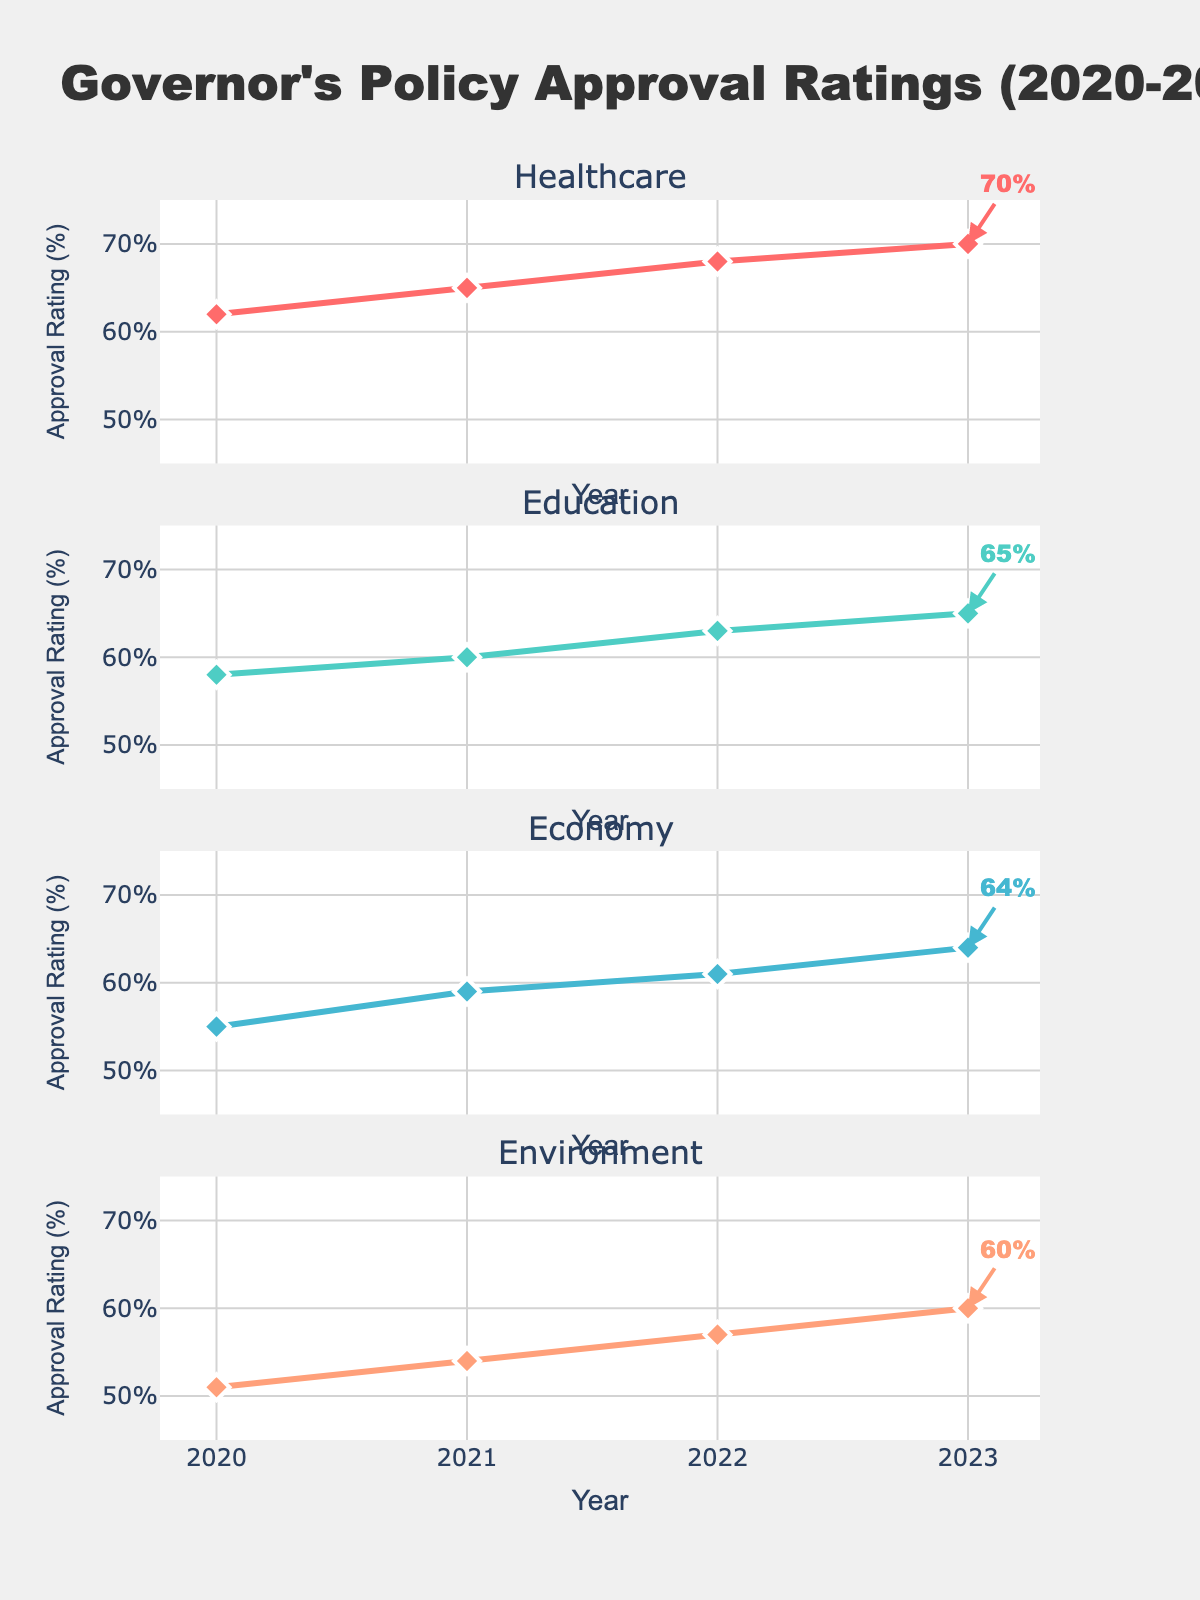What are the positions displayed in the figure? The figure has a y-axis displaying ice hockey player positions. The listed positions are: Forward, Defenseman, Goalie, Center, and Winger.
Answer: Forward, Defenseman, Goalie, Center, Winger What is the title of the figure? The title of the figure is displayed at the top and it indicates the subject of the chart. It reads, "Ice Hockey Player Statistics by Position."
Answer: Ice Hockey Player Statistics by Position Which position has the highest number of goals? By examining the horizontal bars under the "Goals" subplot, the position with the longest bar represents the highest number. Winger has the longest bar.
Answer: Winger How many assists do Centers have compared to Forwards? Under the "Assists" subplot, comparing the bars for Center and Forward shows that Center has a slightly longer bar than Forward. Center has 41 assists, while Forward has 35 assists. The difference is 41 - 35 = 6.
Answer: 6 What are the units for the "Penalty Minutes" axis? Looking at the x-axis label of the "Penalty Minutes" subplot, we can see that it indicates "Penalty Minutes" directly. The units are minutes.
Answer: minutes Which position has the lowest Plus/Minus rating? By examining the "Plus/Minus" subplot, Defenseman has the shortest bar, indicating a negative value of -3, which is the lowest rating.
Answer: Defenseman How does the number of goals for Forwards compare to Centers? From the "Goals" subplot, we see that Forward scored 22 goals and Center scored 18 goals. The difference is 22 - 18 = 4 goals.
Answer: 4 Which position has played the fewest games, and how many? By looking at the "Games Played" subplot, Goalie has the shortest bar indicating they played the fewest games, which is 38 games.
Answer: Goalie, 38 Which statistic varies the most among positions? The variance can be visually estimated by seeing which subplot has the most uneven bar lengths. "Penalty Minutes" has the most noticeable variation, especially since Defenseman has 62 minutes and Goalie has only 4.
Answer: Penalty Minutes 